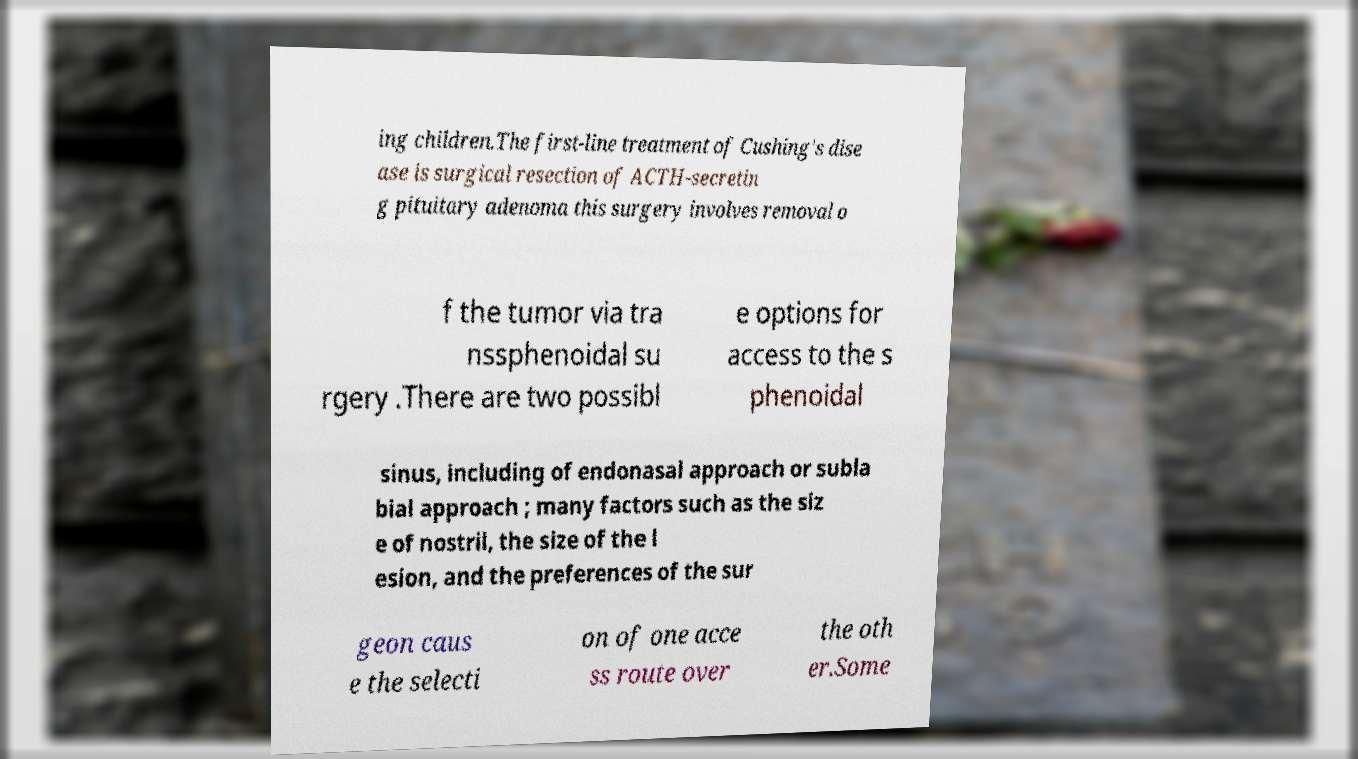Could you assist in decoding the text presented in this image and type it out clearly? ing children.The first-line treatment of Cushing's dise ase is surgical resection of ACTH-secretin g pituitary adenoma this surgery involves removal o f the tumor via tra nssphenoidal su rgery .There are two possibl e options for access to the s phenoidal sinus, including of endonasal approach or subla bial approach ; many factors such as the siz e of nostril, the size of the l esion, and the preferences of the sur geon caus e the selecti on of one acce ss route over the oth er.Some 